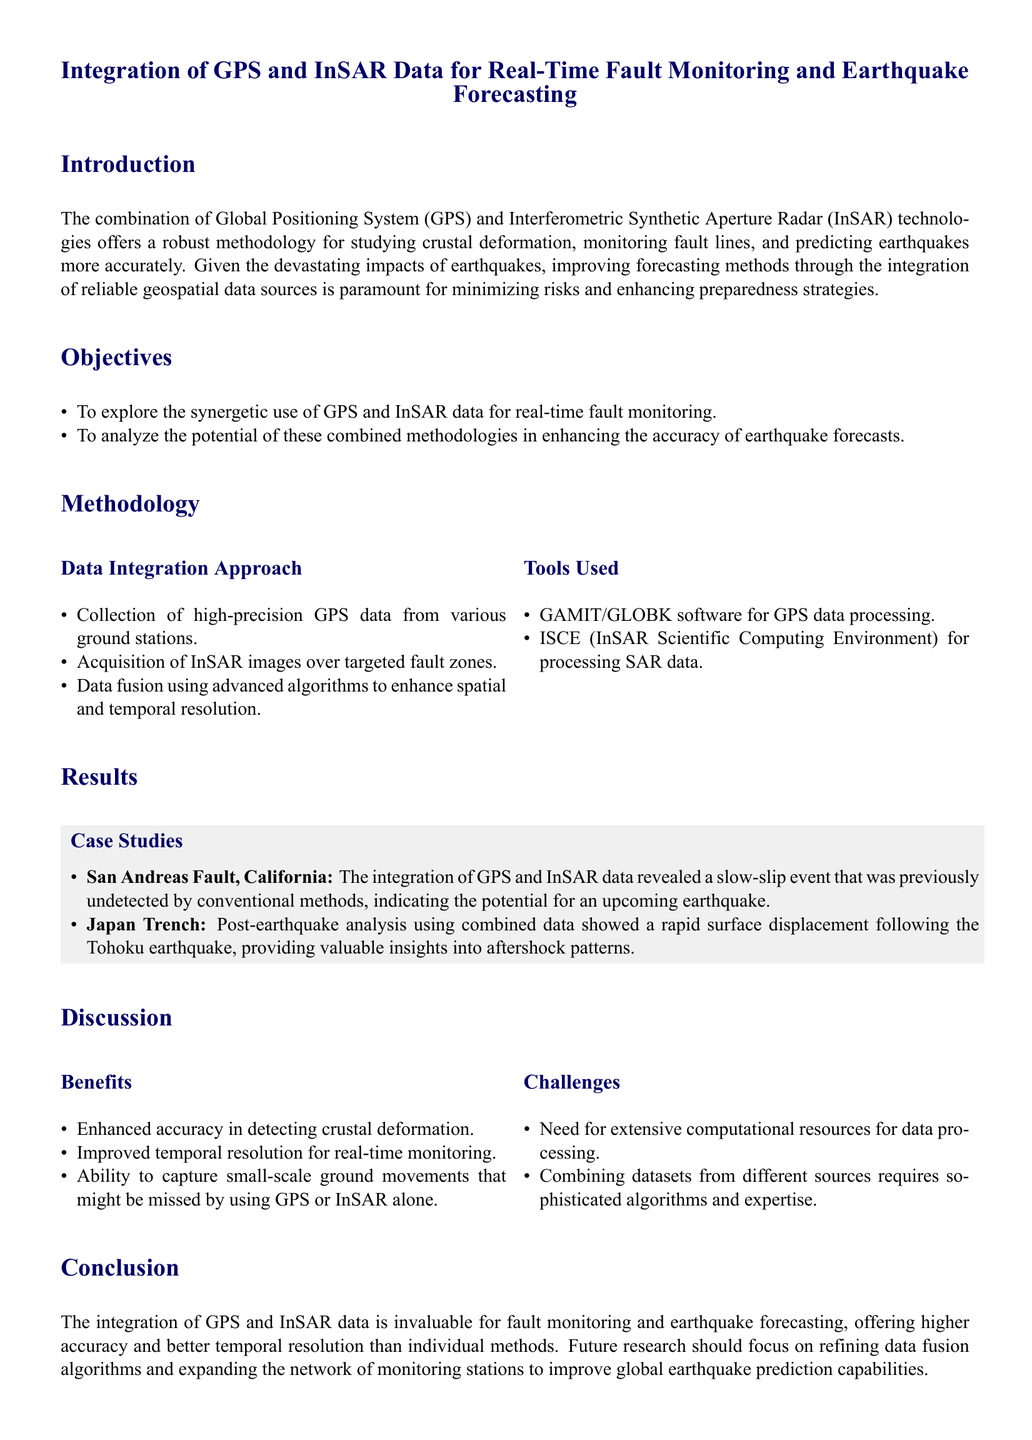What is the main topic of the document? The main topic addresses the integration of GPS and InSAR data for real-time fault monitoring and earthquake forecasting.
Answer: Integration of GPS and InSAR Data for Real-Time Fault Monitoring and Earthquake Forecasting What are the two technologies being integrated? The two technologies mentioned in the document for integration are GPS and InSAR.
Answer: GPS and InSAR What fault is identified in the case study? The case study focuses on the San Andreas Fault, revealing important findings related to earthquake prediction.
Answer: San Andreas Fault What software is used for GPS data processing? The document mentions GAMIT/GLOBK software specifically for processing GPS data.
Answer: GAMIT/GLOBK What is one challenge related to data integration? The document highlights the need for extensive computational resources as one of the challenges in integrating these datasets.
Answer: Extensive computational resources How does the integration of GPS and InSAR data improve monitoring? The combined methodologies result in enhanced accuracy in detecting crustal deformation, improving earthquake forecasting methodologies.
Answer: Enhanced accuracy in detecting crustal deformation Which earthquake's post-analysis is mentioned in the case studies? The post-earthquake analysis mentioned is related to the Tohoku earthquake.
Answer: Tohoku earthquake What is the recommendation for future research? Future research should focus on refining data fusion algorithms and expanding the network of monitoring stations.
Answer: Refining data fusion algorithms and expanding the network of monitoring stations 